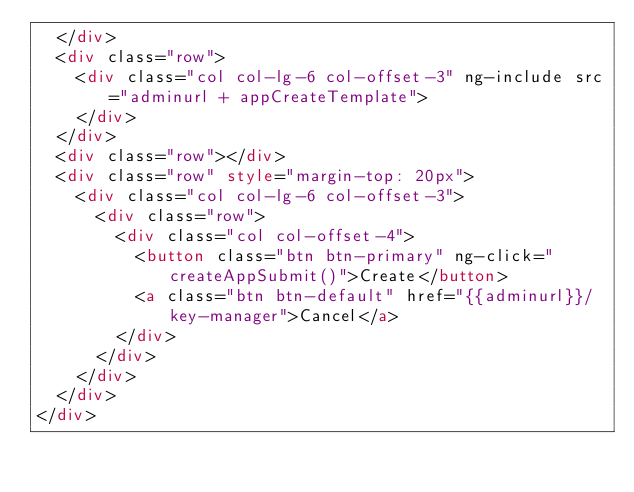<code> <loc_0><loc_0><loc_500><loc_500><_HTML_>	</div>
	<div class="row">
		<div class="col col-lg-6 col-offset-3" ng-include src="adminurl + appCreateTemplate">
		</div>
	</div>
	<div class="row"></div>
	<div class="row" style="margin-top: 20px">
		<div class="col col-lg-6 col-offset-3">
			<div class="row">
				<div class="col col-offset-4">
					<button class="btn btn-primary" ng-click="createAppSubmit()">Create</button>
					<a class="btn btn-default" href="{{adminurl}}/key-manager">Cancel</a>
				</div>
			</div>
		</div>
	</div>
</div></code> 